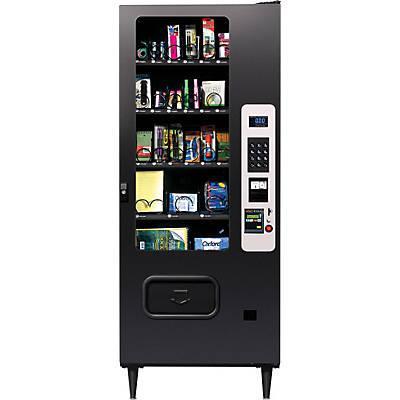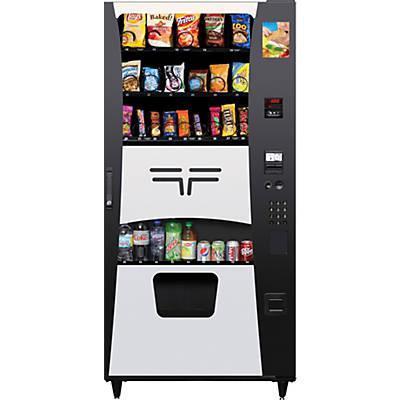The first image is the image on the left, the second image is the image on the right. Given the left and right images, does the statement "There is at least one vending machine that has three total candy compartments." hold true? Answer yes or no. No. 